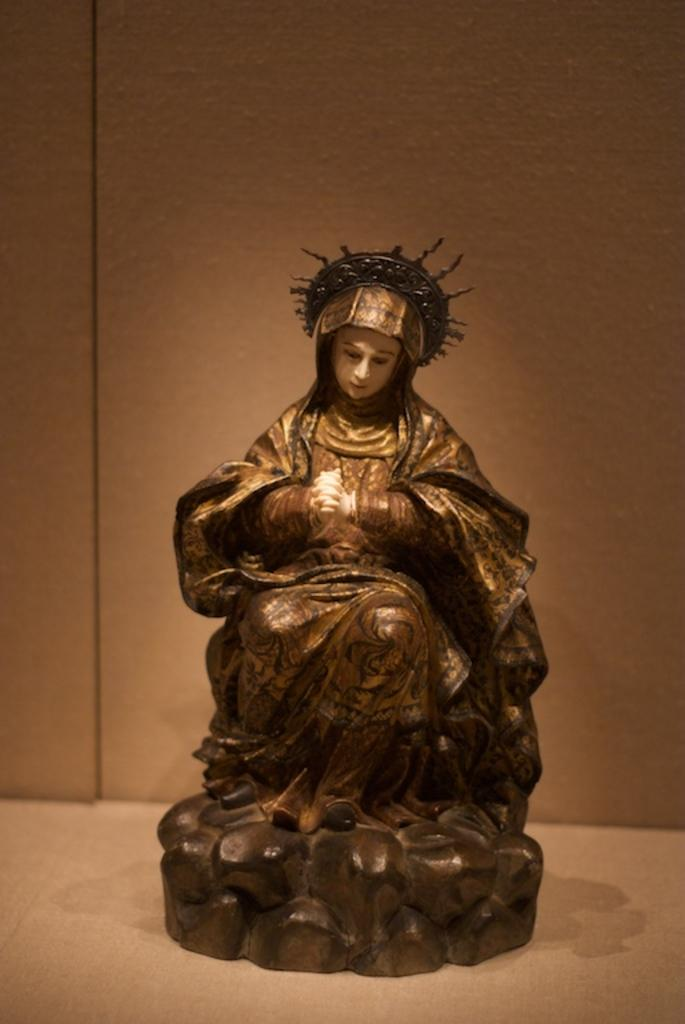What is the main subject of the image? There is a statue in the image. Can you describe the statue? The statue is of a woman. What type of store can be seen in the background of the image? There is no store present in the image; it only features a statue of a woman. 